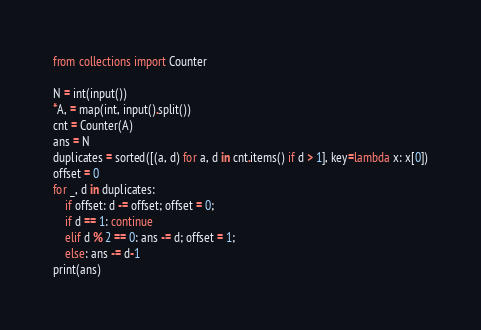Convert code to text. <code><loc_0><loc_0><loc_500><loc_500><_Python_>from collections import Counter

N = int(input())
*A, = map(int, input().split())
cnt = Counter(A)
ans = N
duplicates = sorted([(a, d) for a, d in cnt.items() if d > 1], key=lambda x: x[0])
offset = 0
for _, d in duplicates:
    if offset: d -= offset; offset = 0;
    if d == 1: continue
    elif d % 2 == 0: ans -= d; offset = 1;
    else: ans -= d-1
print(ans)</code> 